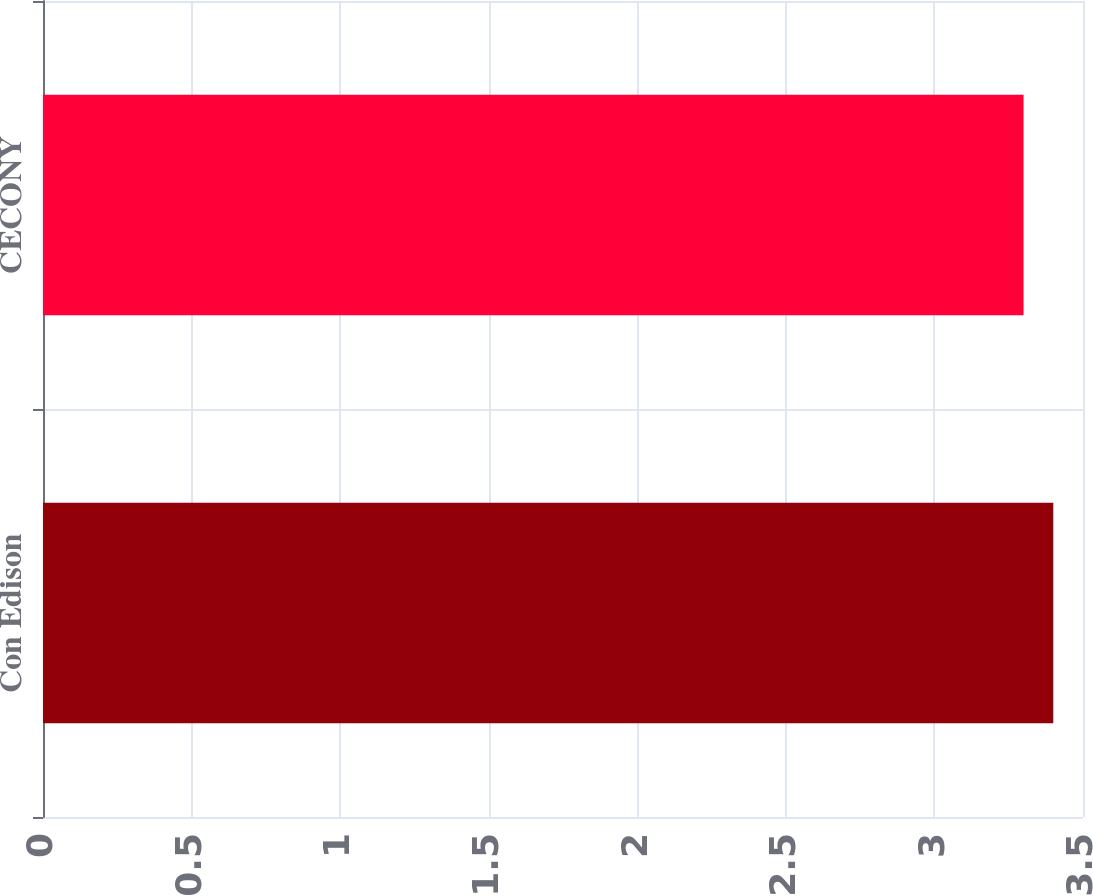<chart> <loc_0><loc_0><loc_500><loc_500><bar_chart><fcel>Con Edison<fcel>CECONY<nl><fcel>3.4<fcel>3.3<nl></chart> 